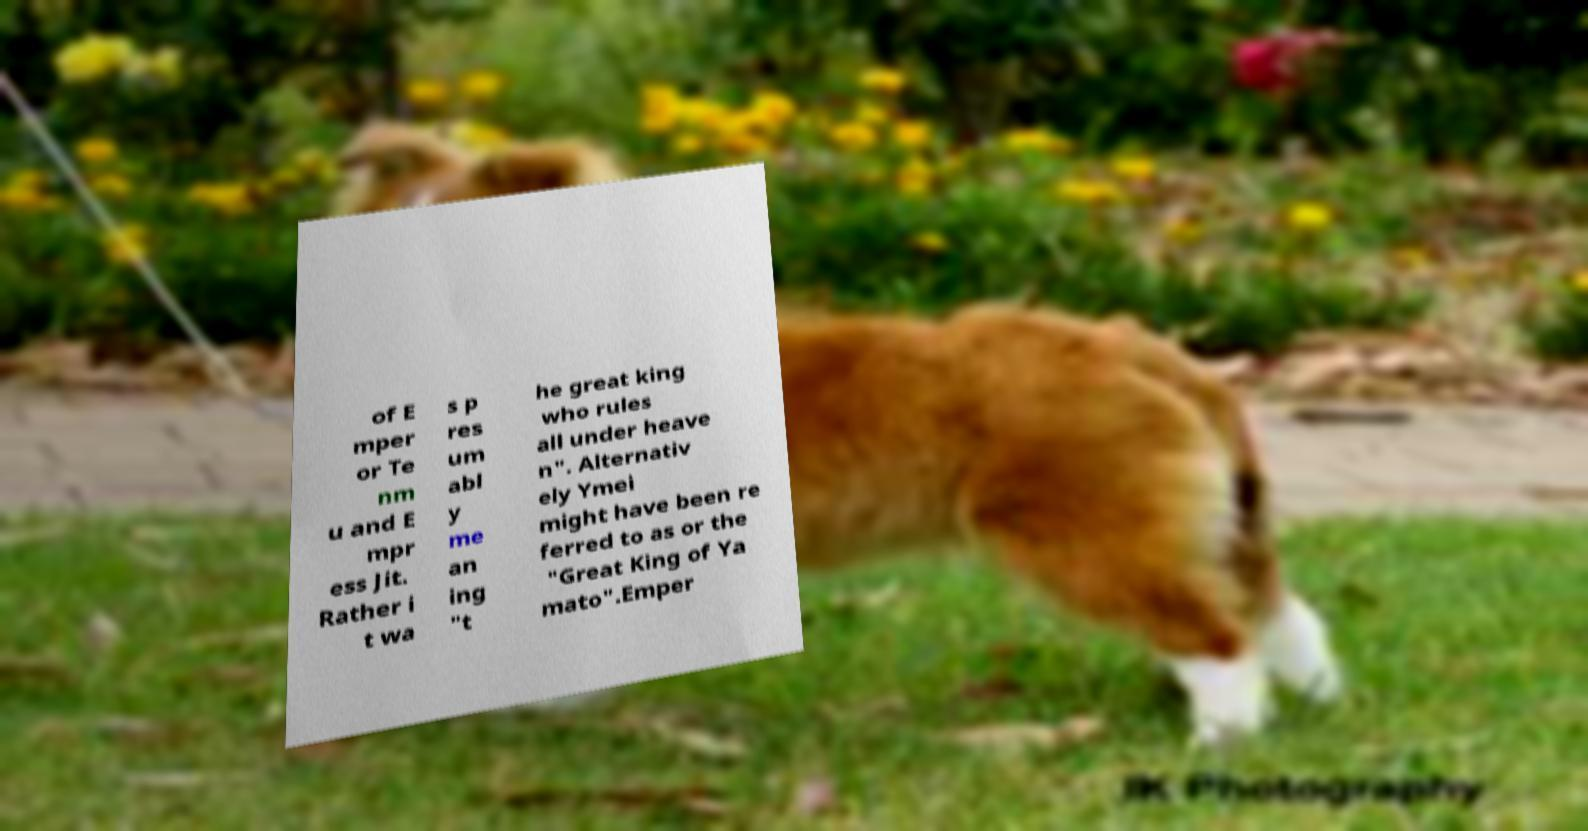Please identify and transcribe the text found in this image. of E mper or Te nm u and E mpr ess Jit. Rather i t wa s p res um abl y me an ing "t he great king who rules all under heave n". Alternativ ely Ymei might have been re ferred to as or the "Great King of Ya mato".Emper 